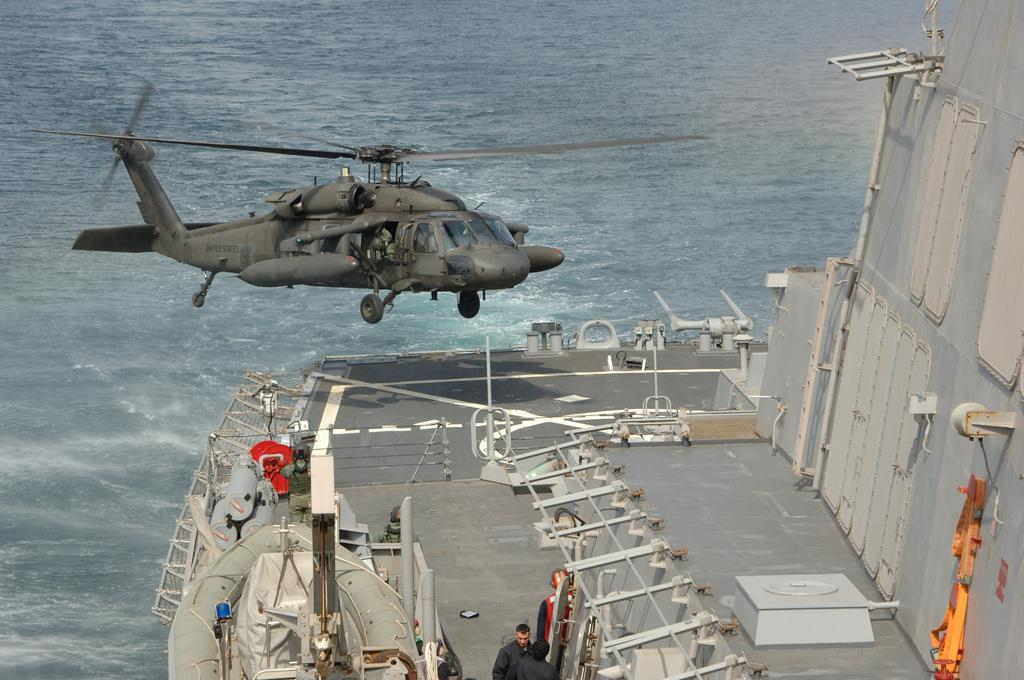What is flying in the air in the image? There is a helicopter flying in the air in the image. What else can be seen in the image besides the helicopter? There is a boat and two people standing on a platform in the image. What is visible in the background of the image? There is water visible in the background of the image. What type of soda is being served on the platform in the image? There is no soda present in the image; it features a helicopter flying in the air, a boat, and two people standing on a platform. What color is the coat worn by the person on the platform in the image? There is no coat visible in the image; the two people on the platform are not wearing any coats. 